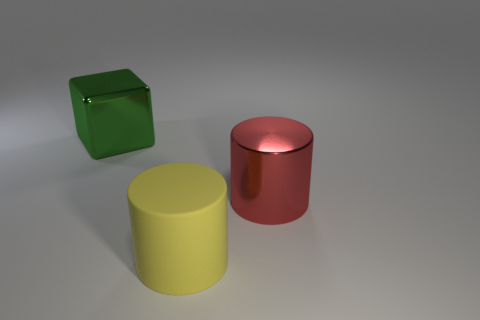Subtract all red cylinders. How many cylinders are left? 1 Add 3 matte objects. How many objects exist? 6 Add 2 large yellow things. How many large yellow things are left? 3 Add 1 small blue matte objects. How many small blue matte objects exist? 1 Subtract 0 brown spheres. How many objects are left? 3 Subtract all cubes. How many objects are left? 2 Subtract all cyan cylinders. Subtract all cyan cubes. How many cylinders are left? 2 Subtract all tiny matte things. Subtract all large metallic cylinders. How many objects are left? 2 